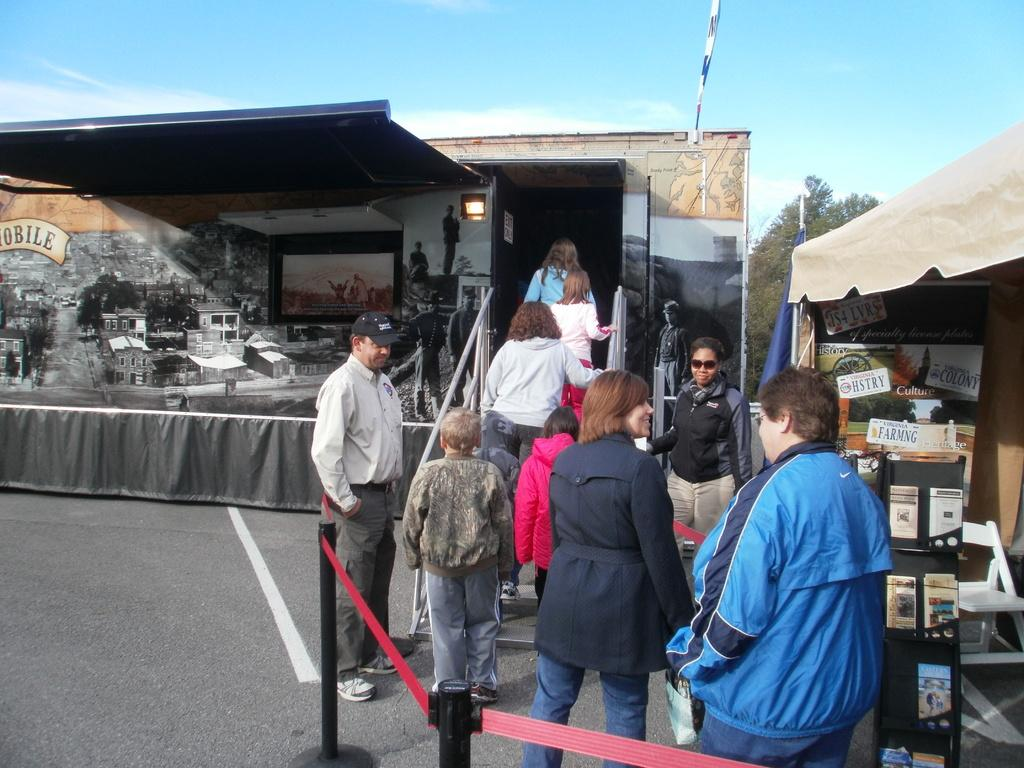<image>
Summarize the visual content of the image. People are lining up to go in a trailer and to their right are Virginia licence plates. 